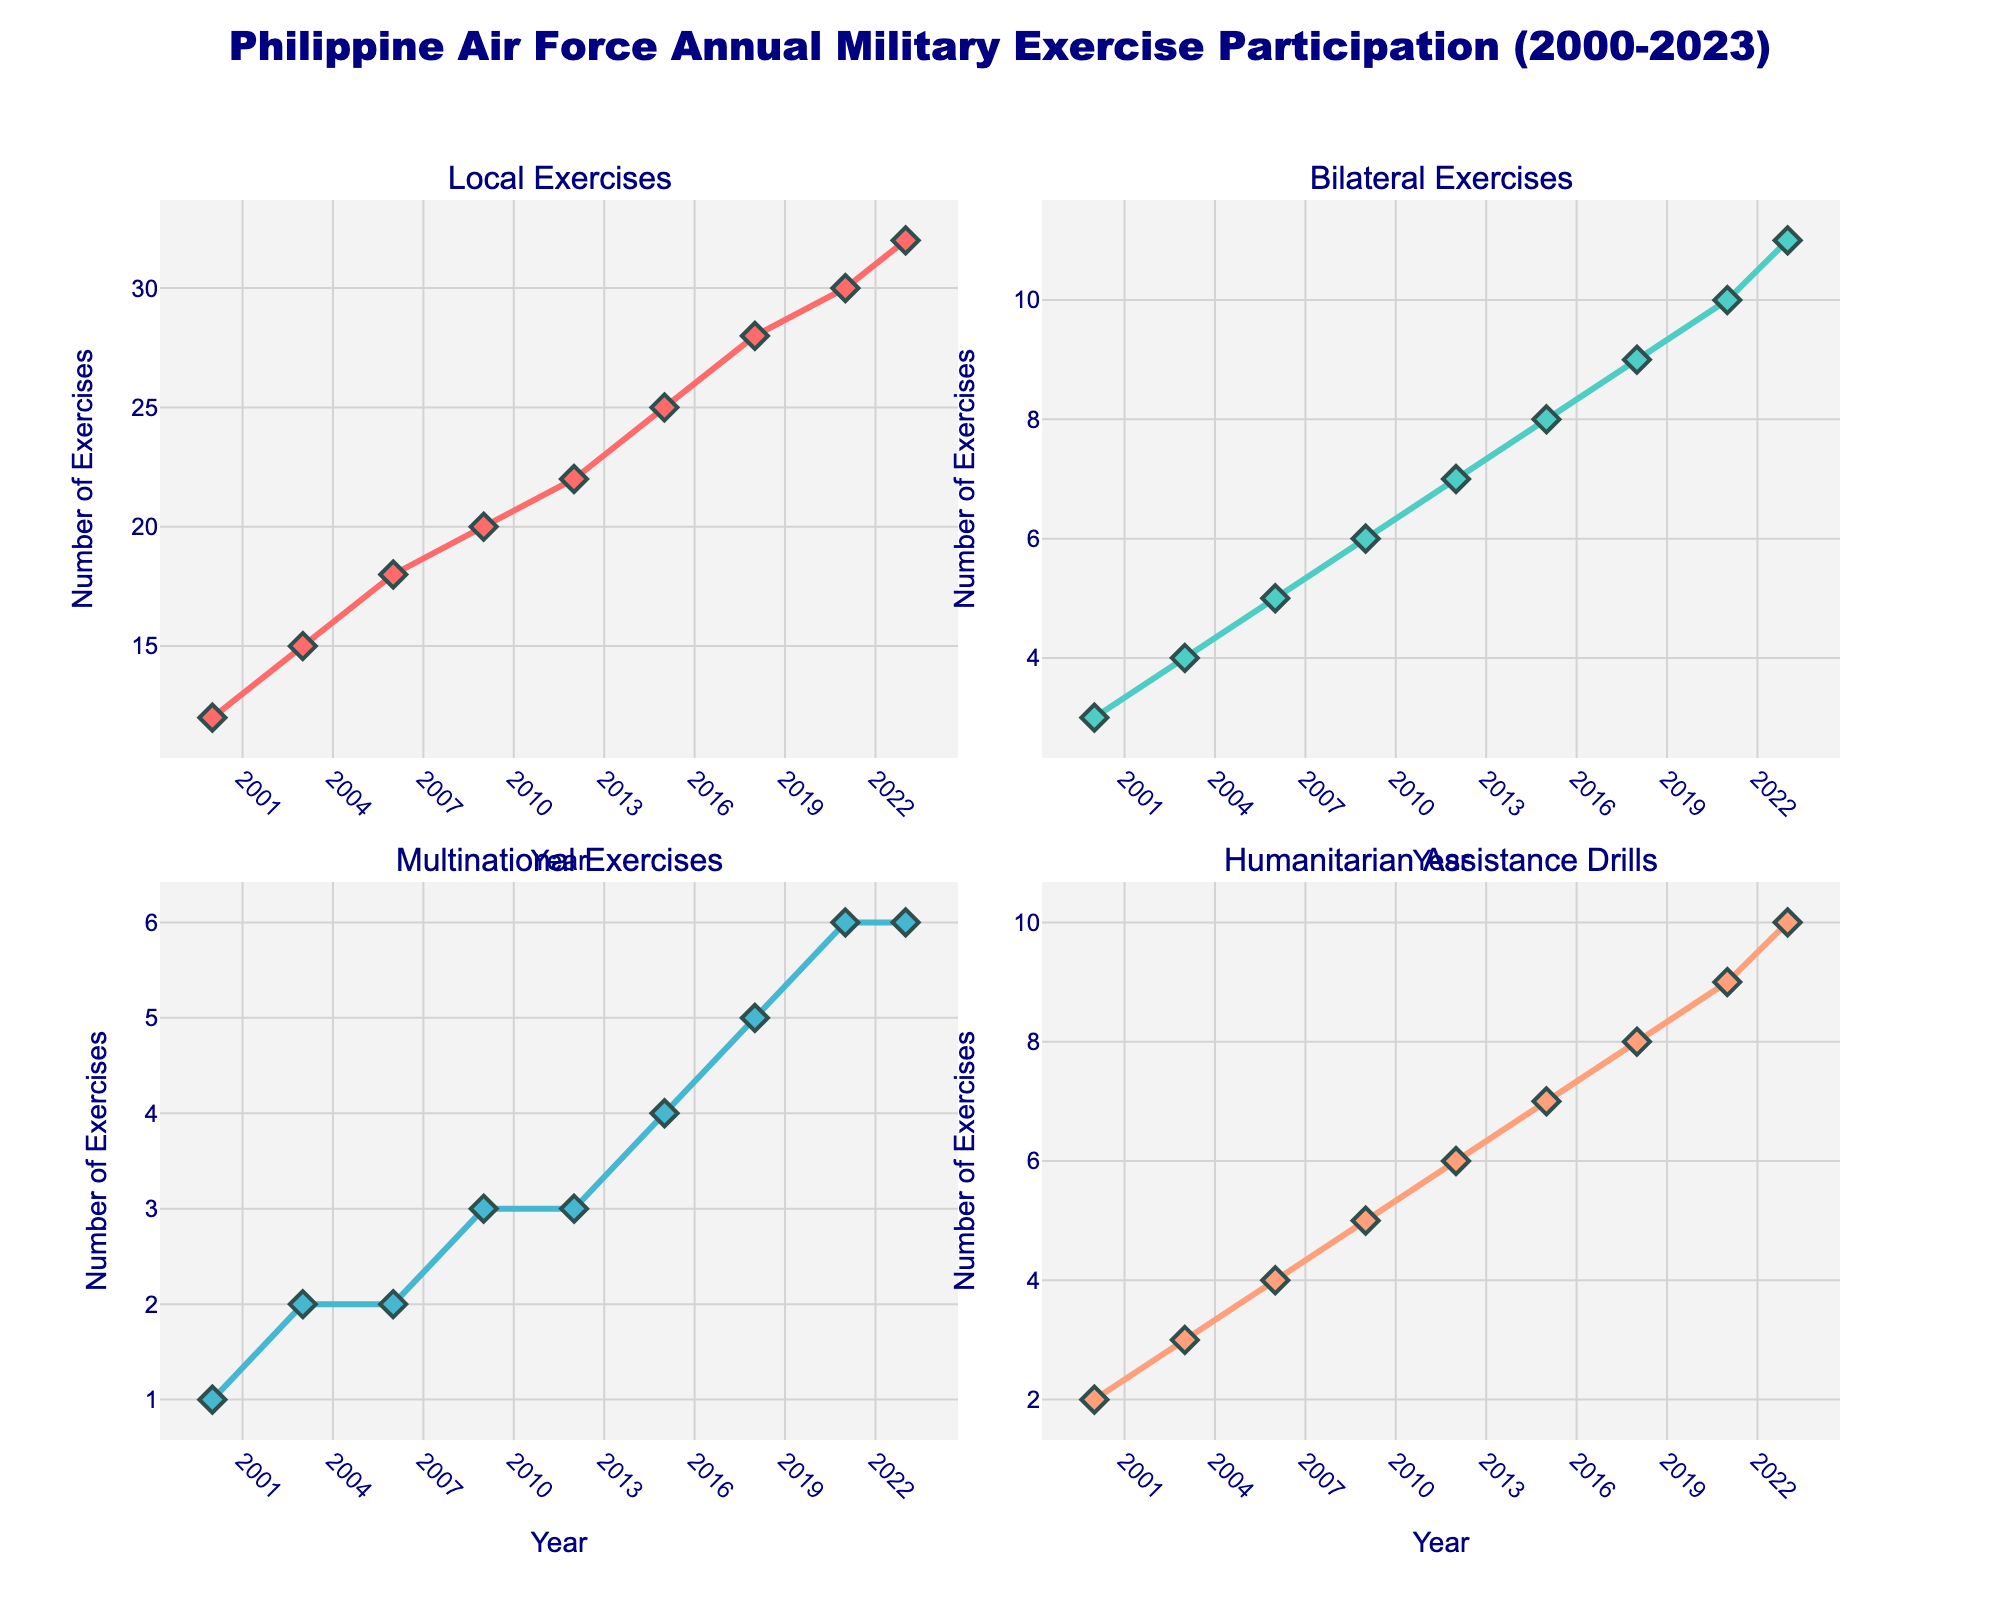What years are displayed on the x-axis of the subplots? The x-axis of each subplot shows the years ranging from 2000 to 2023. The tick marks are displayed at intervals of 3 years: 2000, 2003, 2006, 2009, 2012, 2015, 2018, 2021, and 2023.
Answer: 2000-2023 Which exercise type had the highest participation rate in 2023? By looking at the 2023 data points across all subplots, 'Local Exercises' had the highest participation rate with 32 exercises.
Answer: Local Exercises How did the number of Bilateral Exercises change from 2009 to 2021? The Bilateral Exercises participation rate increased from 6 exercises in 2009 to 10 exercises in 2021. Therefore, the number increased by 4 exercises over this period.
Answer: Increased by 4 exercises In which year did all exercise types have an increase in participation compared to the previous data point? All exercise types showed an increment in participation in each following data point. For instance, from 2018 to 2021, all exercise types increased: Local Exercises (28 to 30), Bilateral Exercises (9 to 10), Multinational Exercises (5 to 6), and Humanitarian Assistance Drills (8 to 9).
Answer: 2021 What is the trend of Humanitarian Assistance Drills from 2000 to 2023? The trend of Humanitarian Assistance Drills shows a consistent increase from 2 exercises in 2000 to 10 exercises in 2023. It demonstrates a steady upward trend over the years.
Answer: Increasing Which exercise type had the least variation in participation rates over the years? By examining the trends, 'Multinational Exercises' had the least variation. The participation rates only fluctuated slightly between 1 and 6 exercises from 2000 to 2023.
Answer: Multinational Exercises Compare the participation rates of Local Exercises and Bilateral Exercises in 2015. Which was higher and by how much? In 2015, the participation rate for Local Exercises was 25 and for Bilateral Exercises was 8. The Local Exercises had 17 more participations than Bilateral Exercises.
Answer: Local Exercises by 17 What is the total number of Local Exercises and Bilateral Exercises combined in 2003? The sum of Local Exercises (15) and Bilateral Exercises (4) in 2003 equals 19 exercises combined.
Answer: 19 How did Multinational Exercises change from 2000 to 2006? Multinational Exercises increased from 1 exercise in 2000 to 2 exercises in 2006, thus indicating an increment of 1 exercise during this period.
Answer: Increased by 1 Which exercise type showed the largest percentage increase from 2000 to 2023? Local Exercises increased from 12 in 2000 to 32 in 2023. The percentage increase can be calculated as ((32-12)/12) * 100 = 166.67%. No other exercise type matches this percentage increase.
Answer: Local Exercises by 166.67% 